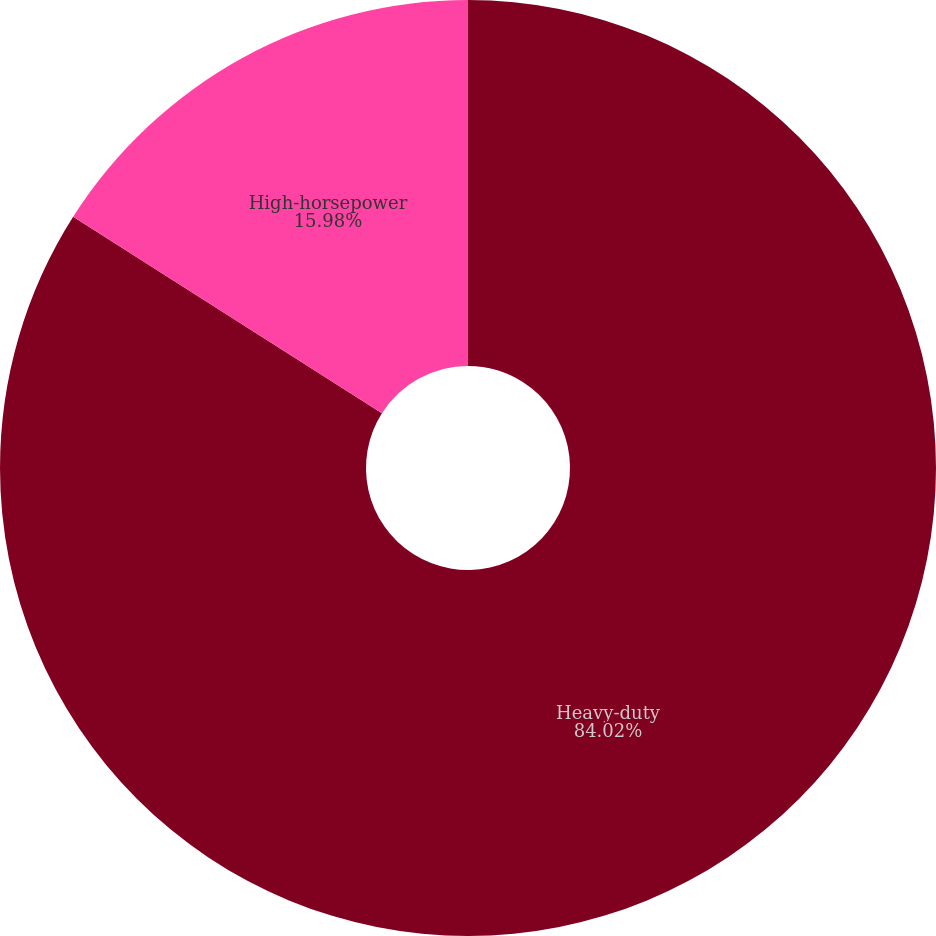Convert chart to OTSL. <chart><loc_0><loc_0><loc_500><loc_500><pie_chart><fcel>Heavy-duty<fcel>High-horsepower<nl><fcel>84.02%<fcel>15.98%<nl></chart> 